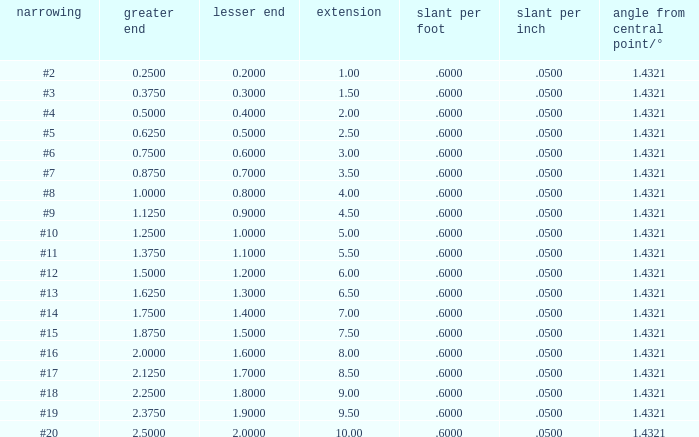Can you give me this table as a dict? {'header': ['narrowing', 'greater end', 'lesser end', 'extension', 'slant per foot', 'slant per inch', 'angle from central point/°'], 'rows': [['#2', '0.2500', '0.2000', '1.00', '.6000', '.0500', '1.4321'], ['#3', '0.3750', '0.3000', '1.50', '.6000', '.0500', '1.4321'], ['#4', '0.5000', '0.4000', '2.00', '.6000', '.0500', '1.4321'], ['#5', '0.6250', '0.5000', '2.50', '.6000', '.0500', '1.4321'], ['#6', '0.7500', '0.6000', '3.00', '.6000', '.0500', '1.4321'], ['#7', '0.8750', '0.7000', '3.50', '.6000', '.0500', '1.4321'], ['#8', '1.0000', '0.8000', '4.00', '.6000', '.0500', '1.4321'], ['#9', '1.1250', '0.9000', '4.50', '.6000', '.0500', '1.4321'], ['#10', '1.2500', '1.0000', '5.00', '.6000', '.0500', '1.4321'], ['#11', '1.3750', '1.1000', '5.50', '.6000', '.0500', '1.4321'], ['#12', '1.5000', '1.2000', '6.00', '.6000', '.0500', '1.4321'], ['#13', '1.6250', '1.3000', '6.50', '.6000', '.0500', '1.4321'], ['#14', '1.7500', '1.4000', '7.00', '.6000', '.0500', '1.4321'], ['#15', '1.8750', '1.5000', '7.50', '.6000', '.0500', '1.4321'], ['#16', '2.0000', '1.6000', '8.00', '.6000', '.0500', '1.4321'], ['#17', '2.1250', '1.7000', '8.50', '.6000', '.0500', '1.4321'], ['#18', '2.2500', '1.8000', '9.00', '.6000', '.0500', '1.4321'], ['#19', '2.3750', '1.9000', '9.50', '.6000', '.0500', '1.4321'], ['#20', '2.5000', '2.0000', '10.00', '.6000', '.0500', '1.4321']]} Which Taper/ft that has a Large end smaller than 0.5, and a Taper of #2? 0.6. 